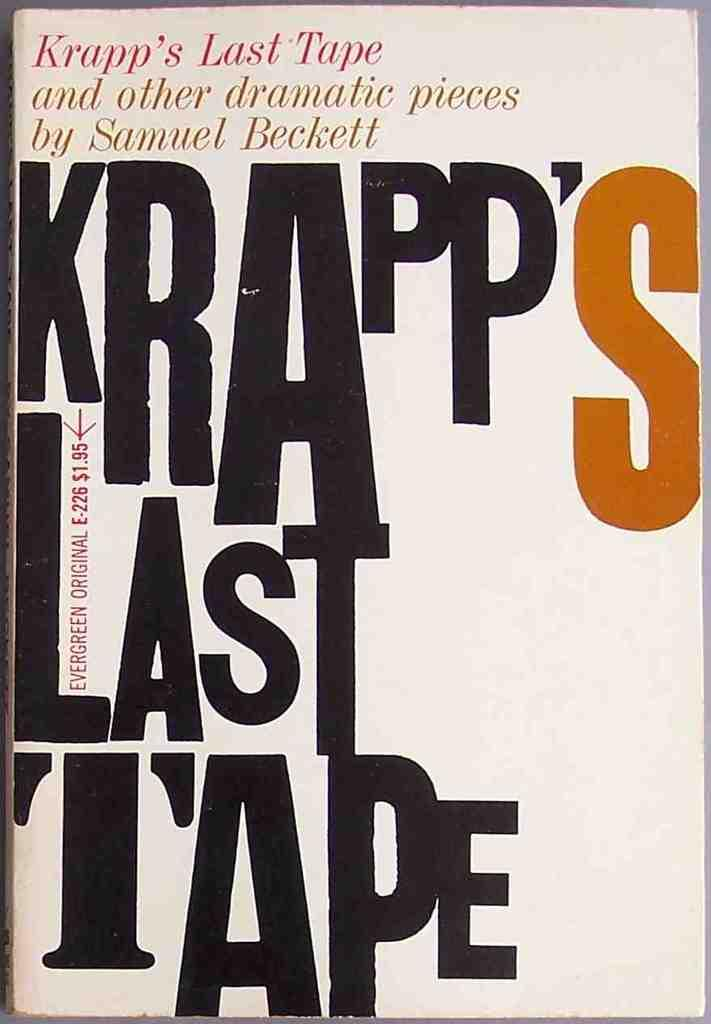What is the main subject of the image? The main subject of the image is a book cover. What can be seen on the book cover? There is text visible on the book cover. What actor is saying good-bye on the book cover? There is no actor present on the book cover, and the image does not depict any good-byes. 